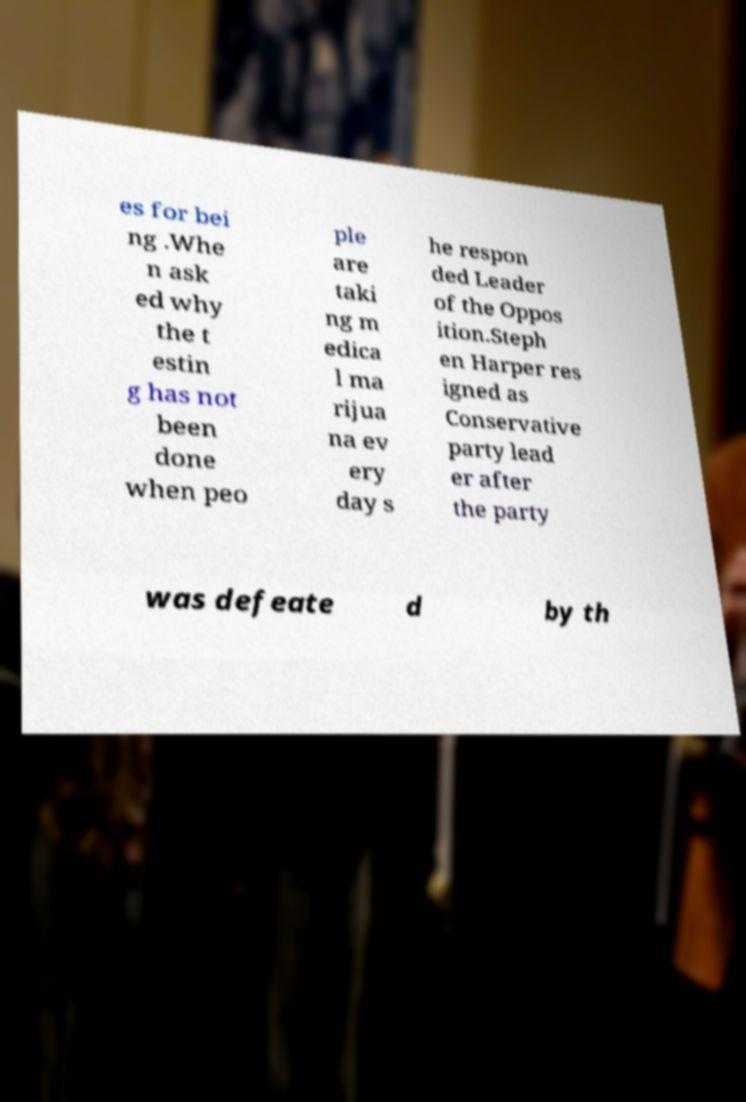What messages or text are displayed in this image? I need them in a readable, typed format. es for bei ng .Whe n ask ed why the t estin g has not been done when peo ple are taki ng m edica l ma rijua na ev ery day s he respon ded Leader of the Oppos ition.Steph en Harper res igned as Conservative party lead er after the party was defeate d by th 